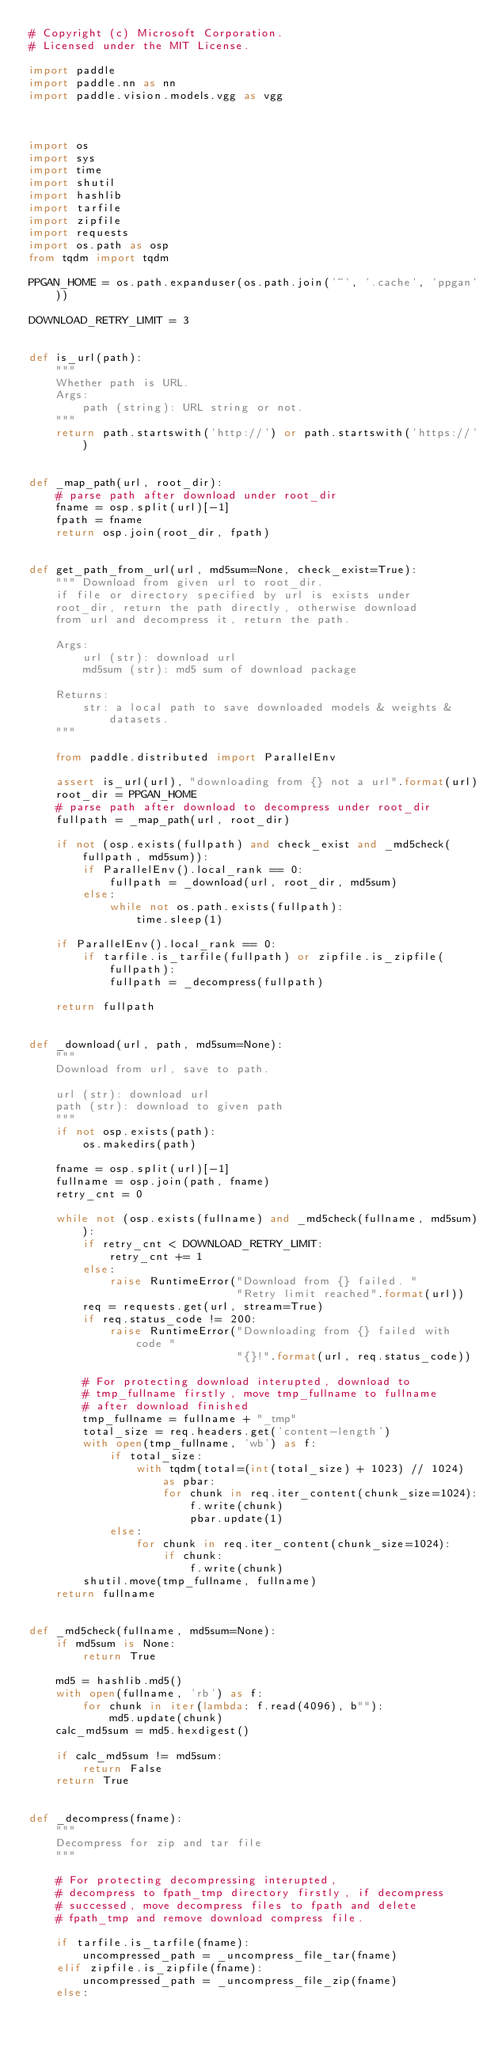<code> <loc_0><loc_0><loc_500><loc_500><_Python_># Copyright (c) Microsoft Corporation.
# Licensed under the MIT License.

import paddle
import paddle.nn as nn
import paddle.vision.models.vgg as vgg



import os
import sys
import time
import shutil
import hashlib
import tarfile
import zipfile
import requests
import os.path as osp
from tqdm import tqdm

PPGAN_HOME = os.path.expanduser(os.path.join('~', '.cache', 'ppgan'))

DOWNLOAD_RETRY_LIMIT = 3


def is_url(path):
    """
    Whether path is URL.
    Args:
        path (string): URL string or not.
    """
    return path.startswith('http://') or path.startswith('https://')


def _map_path(url, root_dir):
    # parse path after download under root_dir
    fname = osp.split(url)[-1]
    fpath = fname
    return osp.join(root_dir, fpath)


def get_path_from_url(url, md5sum=None, check_exist=True):
    """ Download from given url to root_dir.
    if file or directory specified by url is exists under
    root_dir, return the path directly, otherwise download
    from url and decompress it, return the path.

    Args:
        url (str): download url
        md5sum (str): md5 sum of download package

    Returns:
        str: a local path to save downloaded models & weights & datasets.
    """

    from paddle.distributed import ParallelEnv

    assert is_url(url), "downloading from {} not a url".format(url)
    root_dir = PPGAN_HOME
    # parse path after download to decompress under root_dir
    fullpath = _map_path(url, root_dir)

    if not (osp.exists(fullpath) and check_exist and _md5check(fullpath, md5sum)):
        if ParallelEnv().local_rank == 0:
            fullpath = _download(url, root_dir, md5sum)
        else:
            while not os.path.exists(fullpath):
                time.sleep(1)

    if ParallelEnv().local_rank == 0:
        if tarfile.is_tarfile(fullpath) or zipfile.is_zipfile(fullpath):
            fullpath = _decompress(fullpath)

    return fullpath


def _download(url, path, md5sum=None):
    """
    Download from url, save to path.

    url (str): download url
    path (str): download to given path
    """
    if not osp.exists(path):
        os.makedirs(path)

    fname = osp.split(url)[-1]
    fullname = osp.join(path, fname)
    retry_cnt = 0

    while not (osp.exists(fullname) and _md5check(fullname, md5sum)):
        if retry_cnt < DOWNLOAD_RETRY_LIMIT:
            retry_cnt += 1
        else:
            raise RuntimeError("Download from {} failed. "
                               "Retry limit reached".format(url))
        req = requests.get(url, stream=True)
        if req.status_code != 200:
            raise RuntimeError("Downloading from {} failed with code "
                               "{}!".format(url, req.status_code))

        # For protecting download interupted, download to
        # tmp_fullname firstly, move tmp_fullname to fullname
        # after download finished
        tmp_fullname = fullname + "_tmp"
        total_size = req.headers.get('content-length')
        with open(tmp_fullname, 'wb') as f:
            if total_size:
                with tqdm(total=(int(total_size) + 1023) // 1024) as pbar:
                    for chunk in req.iter_content(chunk_size=1024):
                        f.write(chunk)
                        pbar.update(1)
            else:
                for chunk in req.iter_content(chunk_size=1024):
                    if chunk:
                        f.write(chunk)
        shutil.move(tmp_fullname, fullname)
    return fullname


def _md5check(fullname, md5sum=None):
    if md5sum is None:
        return True

    md5 = hashlib.md5()
    with open(fullname, 'rb') as f:
        for chunk in iter(lambda: f.read(4096), b""):
            md5.update(chunk)
    calc_md5sum = md5.hexdigest()

    if calc_md5sum != md5sum:
        return False
    return True


def _decompress(fname):
    """
    Decompress for zip and tar file
    """

    # For protecting decompressing interupted,
    # decompress to fpath_tmp directory firstly, if decompress
    # successed, move decompress files to fpath and delete
    # fpath_tmp and remove download compress file.

    if tarfile.is_tarfile(fname):
        uncompressed_path = _uncompress_file_tar(fname)
    elif zipfile.is_zipfile(fname):
        uncompressed_path = _uncompress_file_zip(fname)
    else:</code> 